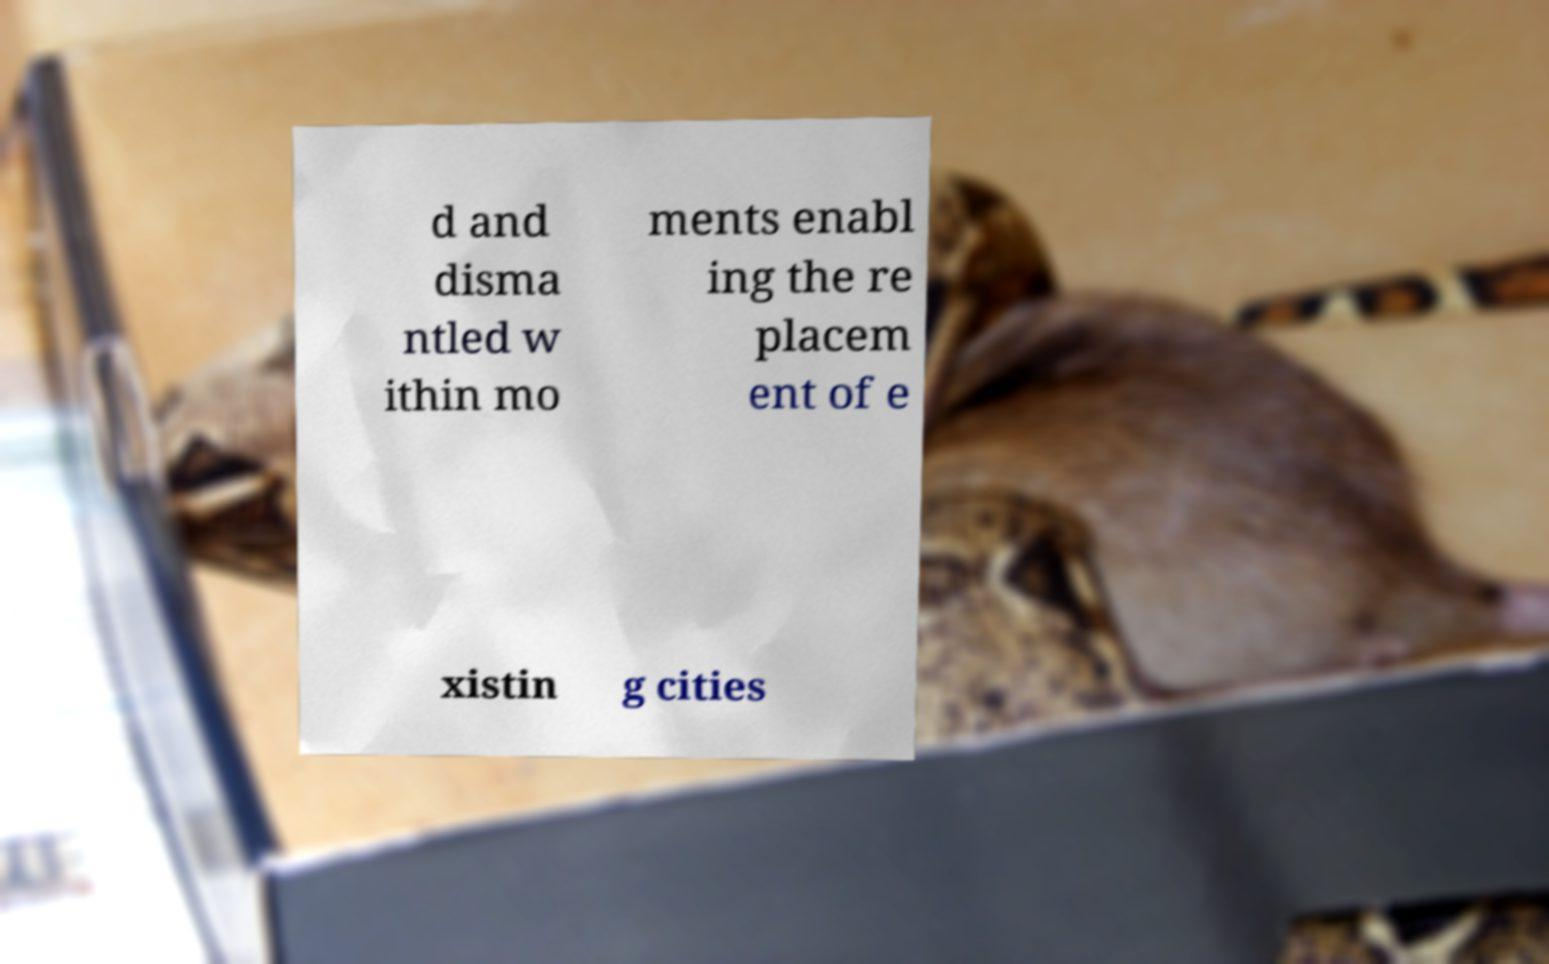Could you assist in decoding the text presented in this image and type it out clearly? d and disma ntled w ithin mo ments enabl ing the re placem ent of e xistin g cities 